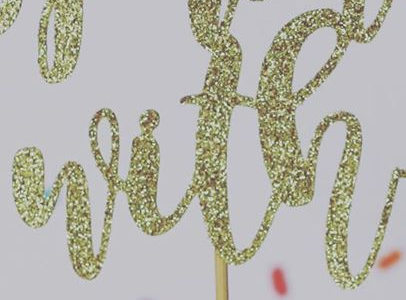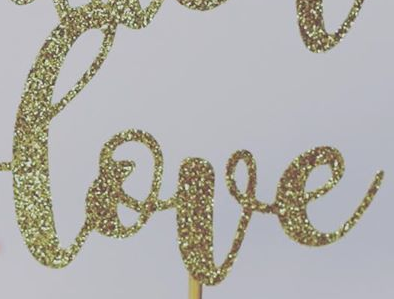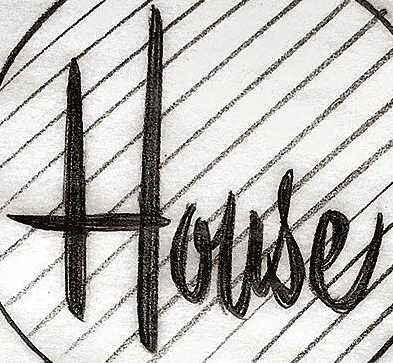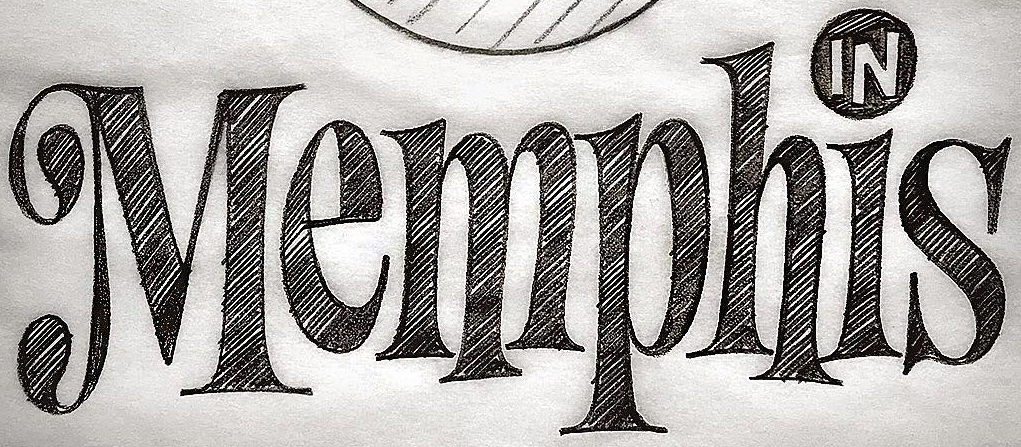Transcribe the words shown in these images in order, separated by a semicolon. with; love; House; Memphis 